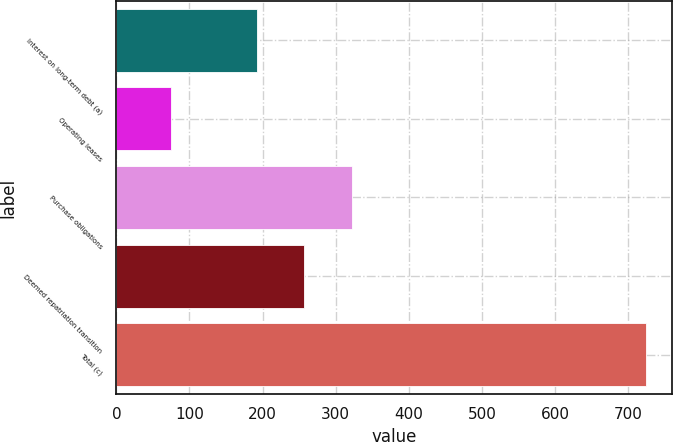Convert chart. <chart><loc_0><loc_0><loc_500><loc_500><bar_chart><fcel>Interest on long-term debt (a)<fcel>Operating leases<fcel>Purchase obligations<fcel>Deemed repatriation transition<fcel>Total (c)<nl><fcel>192<fcel>75<fcel>321.8<fcel>256.9<fcel>724<nl></chart> 